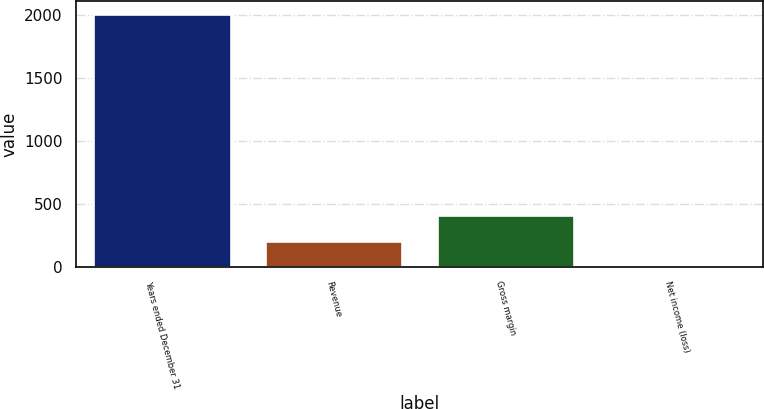Convert chart. <chart><loc_0><loc_0><loc_500><loc_500><bar_chart><fcel>Years ended December 31<fcel>Revenue<fcel>Gross margin<fcel>Net income (loss)<nl><fcel>2011<fcel>205.6<fcel>406.2<fcel>5<nl></chart> 